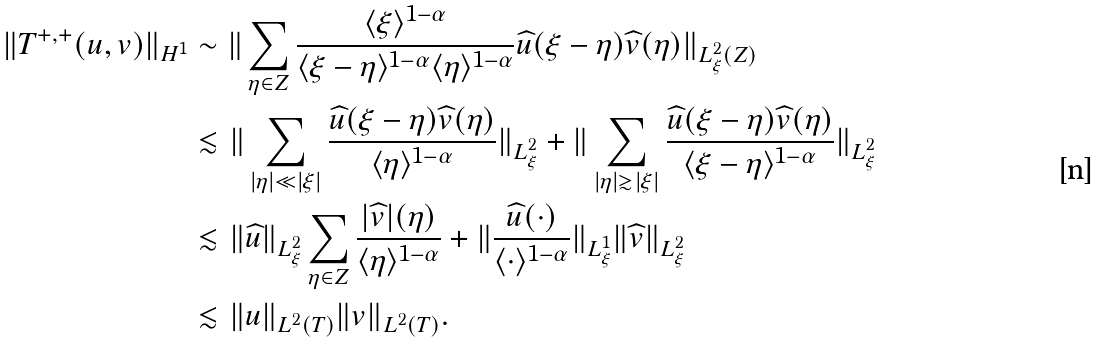<formula> <loc_0><loc_0><loc_500><loc_500>\| T ^ { + , + } ( u , v ) \| _ { H ^ { 1 } } & \sim \| \sum _ { \eta \in Z } \frac { \langle \xi \rangle ^ { 1 - \alpha } } { \langle \xi - \eta \rangle ^ { 1 - \alpha } \langle \eta \rangle ^ { 1 - \alpha } } \widehat { u } ( \xi - \eta ) \widehat { v } ( \eta ) \| _ { L ^ { 2 } _ { \xi } ( Z ) } \\ & \lesssim \| \sum _ { | \eta | \ll | \xi | } \frac { \widehat { u } ( \xi - \eta ) \widehat { v } ( \eta ) } { \langle \eta \rangle ^ { 1 - \alpha } } \| _ { L ^ { 2 } _ { \xi } } + \| \sum _ { | \eta | \gtrsim | \xi | } \frac { \widehat { u } ( \xi - \eta ) \widehat { v } ( \eta ) } { \langle \xi - \eta \rangle ^ { 1 - \alpha } } \| _ { L ^ { 2 } _ { \xi } } \\ & \lesssim \| \widehat { u } \| _ { L ^ { 2 } _ { \xi } } \sum _ { \eta \in Z } \frac { | \widehat { v } | ( \eta ) } { \langle \eta \rangle ^ { 1 - \alpha } } + \| \frac { \widehat { u } ( \cdot ) } { \langle \cdot \rangle ^ { 1 - \alpha } } \| _ { L ^ { 1 } _ { \xi } } \| \widehat { v } \| _ { L ^ { 2 } _ { \xi } } \\ & \lesssim \| u \| _ { L ^ { 2 } ( T ) } \| v \| _ { L ^ { 2 } ( T ) } .</formula> 